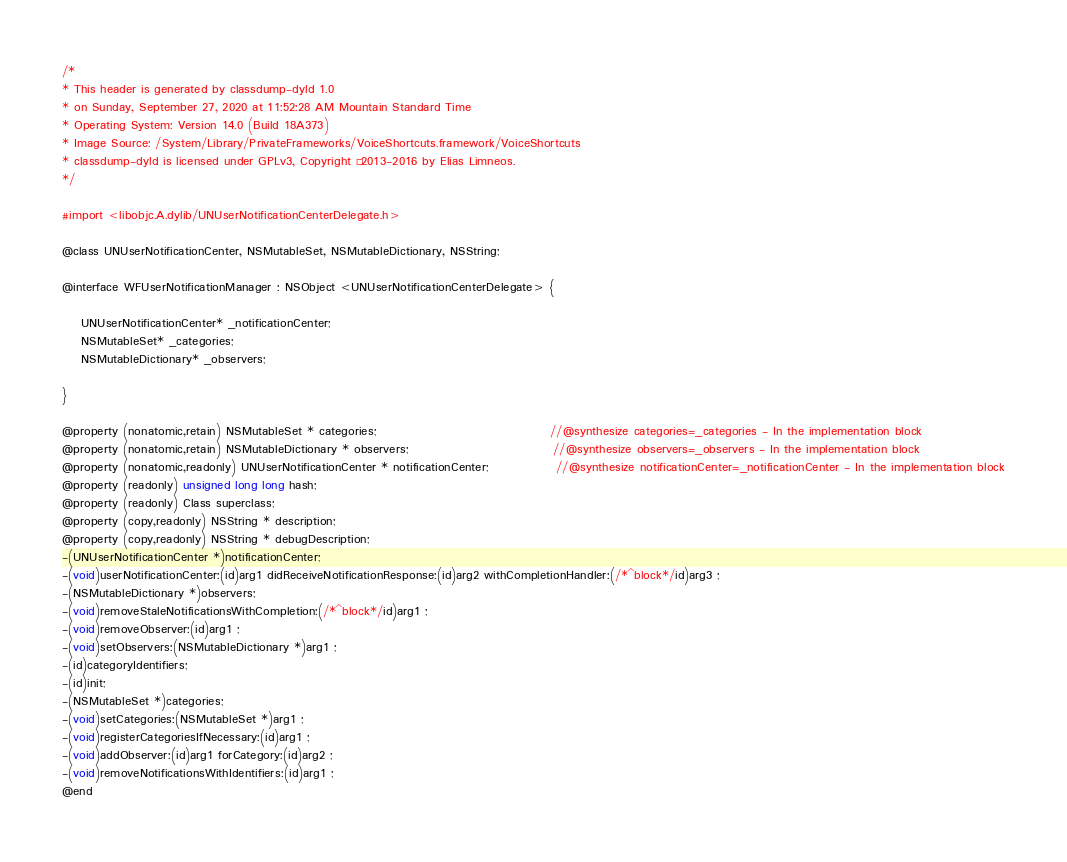<code> <loc_0><loc_0><loc_500><loc_500><_C_>/*
* This header is generated by classdump-dyld 1.0
* on Sunday, September 27, 2020 at 11:52:28 AM Mountain Standard Time
* Operating System: Version 14.0 (Build 18A373)
* Image Source: /System/Library/PrivateFrameworks/VoiceShortcuts.framework/VoiceShortcuts
* classdump-dyld is licensed under GPLv3, Copyright © 2013-2016 by Elias Limneos.
*/

#import <libobjc.A.dylib/UNUserNotificationCenterDelegate.h>

@class UNUserNotificationCenter, NSMutableSet, NSMutableDictionary, NSString;

@interface WFUserNotificationManager : NSObject <UNUserNotificationCenterDelegate> {

	UNUserNotificationCenter* _notificationCenter;
	NSMutableSet* _categories;
	NSMutableDictionary* _observers;

}

@property (nonatomic,retain) NSMutableSet * categories;                                    //@synthesize categories=_categories - In the implementation block
@property (nonatomic,retain) NSMutableDictionary * observers;                              //@synthesize observers=_observers - In the implementation block
@property (nonatomic,readonly) UNUserNotificationCenter * notificationCenter;              //@synthesize notificationCenter=_notificationCenter - In the implementation block
@property (readonly) unsigned long long hash; 
@property (readonly) Class superclass; 
@property (copy,readonly) NSString * description; 
@property (copy,readonly) NSString * debugDescription; 
-(UNUserNotificationCenter *)notificationCenter;
-(void)userNotificationCenter:(id)arg1 didReceiveNotificationResponse:(id)arg2 withCompletionHandler:(/*^block*/id)arg3 ;
-(NSMutableDictionary *)observers;
-(void)removeStaleNotificationsWithCompletion:(/*^block*/id)arg1 ;
-(void)removeObserver:(id)arg1 ;
-(void)setObservers:(NSMutableDictionary *)arg1 ;
-(id)categoryIdentifiers;
-(id)init;
-(NSMutableSet *)categories;
-(void)setCategories:(NSMutableSet *)arg1 ;
-(void)registerCategoriesIfNecessary:(id)arg1 ;
-(void)addObserver:(id)arg1 forCategory:(id)arg2 ;
-(void)removeNotificationsWithIdentifiers:(id)arg1 ;
@end

</code> 